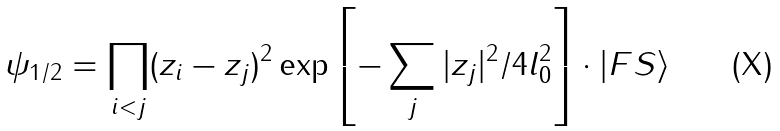<formula> <loc_0><loc_0><loc_500><loc_500>\psi _ { 1 / 2 } = \prod _ { i < j } ( z _ { i } - z _ { j } ) ^ { 2 } \exp \left [ - \sum _ { j } | z _ { j } | ^ { 2 } / 4 l _ { 0 } ^ { 2 } \right ] \cdot | F S \rangle</formula> 